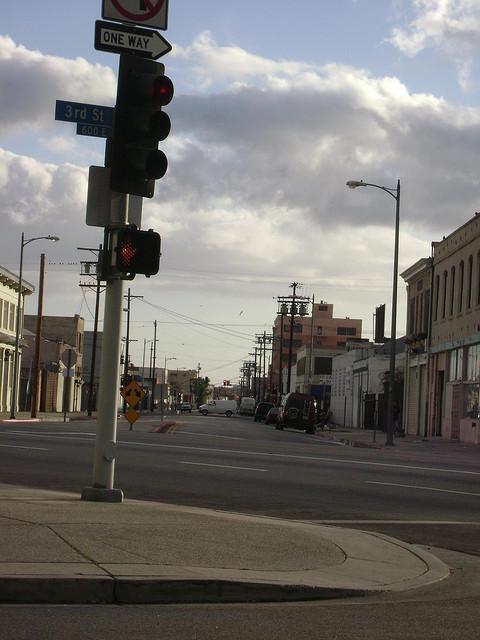How many people are on the couch?
Give a very brief answer. 0. 